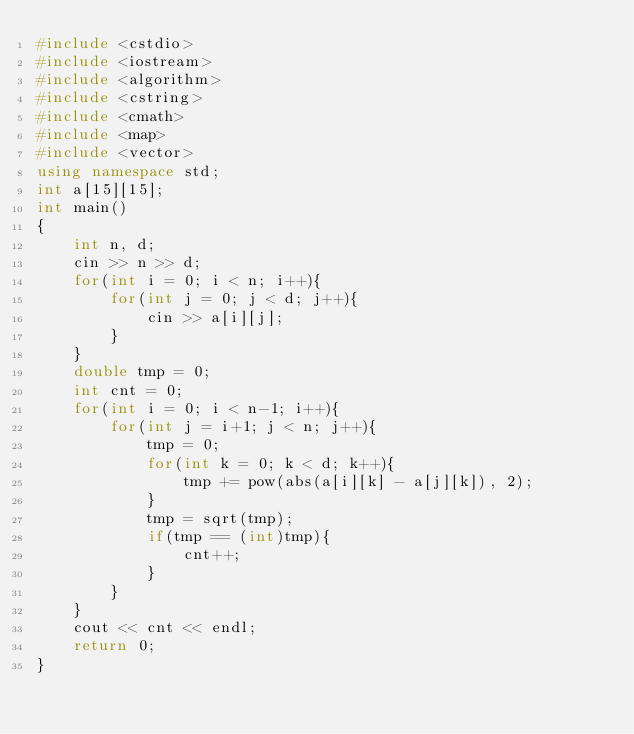<code> <loc_0><loc_0><loc_500><loc_500><_C++_>#include <cstdio>
#include <iostream>
#include <algorithm>
#include <cstring>
#include <cmath>
#include <map>
#include <vector>
using namespace std;
int a[15][15];
int main()
{
    int n, d;
    cin >> n >> d;
    for(int i = 0; i < n; i++){
        for(int j = 0; j < d; j++){
            cin >> a[i][j];
        }
    }
    double tmp = 0;
    int cnt = 0;
    for(int i = 0; i < n-1; i++){
        for(int j = i+1; j < n; j++){
            tmp = 0;
            for(int k = 0; k < d; k++){
                tmp += pow(abs(a[i][k] - a[j][k]), 2);
            }
            tmp = sqrt(tmp);
            if(tmp == (int)tmp){
                cnt++;
            }
        }
    }
    cout << cnt << endl;
    return 0;
}</code> 